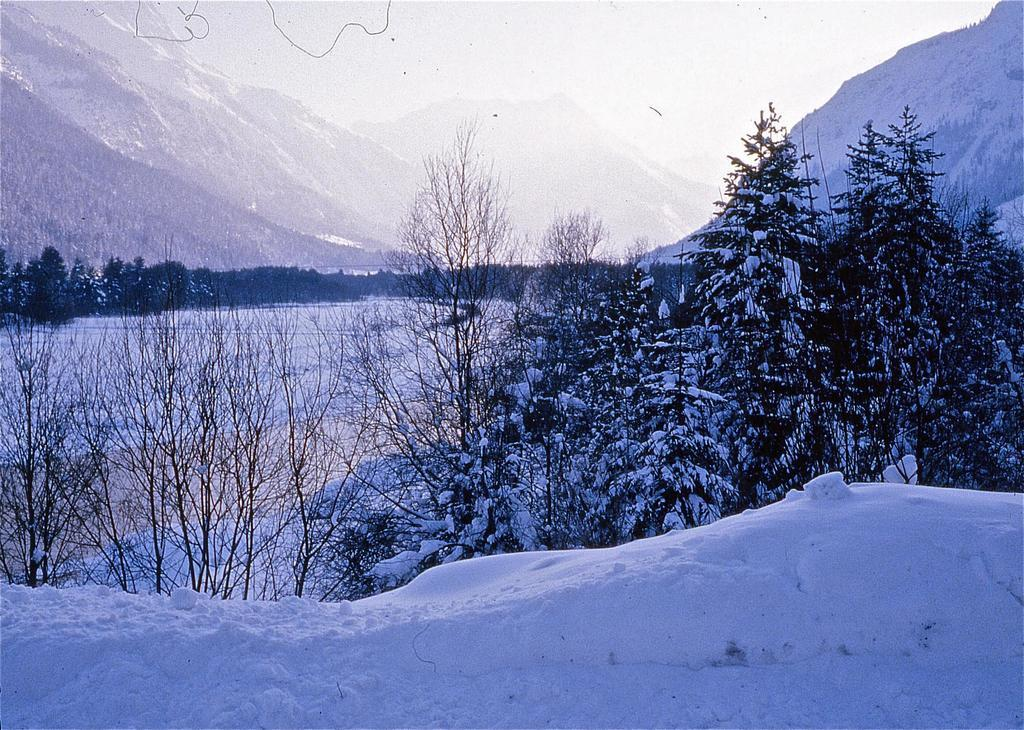What type of landscape is depicted in the image? There is an icy landscape in the image. What type of vegetation can be seen in the image? There are trees in the image. How do the trees appear in the image? Some trees appear to be dried, while others are filled with ice. What geographical features are visible in the image? There are mountains visible in the image. How many books can be seen on the icy landscape in the image? There are no books present in the image; it features an icy landscape with trees and mountains. 